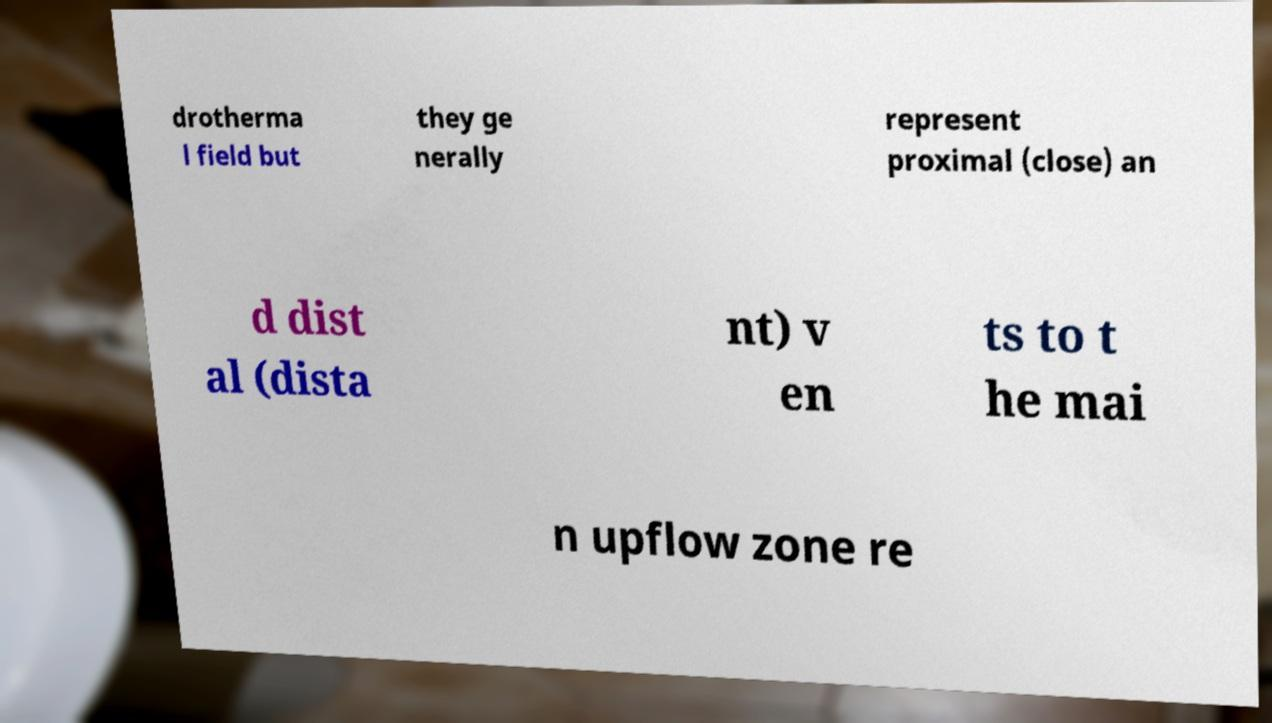There's text embedded in this image that I need extracted. Can you transcribe it verbatim? drotherma l field but they ge nerally represent proximal (close) an d dist al (dista nt) v en ts to t he mai n upflow zone re 